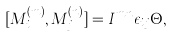Convert formula to latex. <formula><loc_0><loc_0><loc_500><loc_500>[ M _ { i } ^ { ( m ) } , M _ { j } ^ { ( n ) } ] = I ^ { m n } \epsilon _ { i j } \Theta ,</formula> 